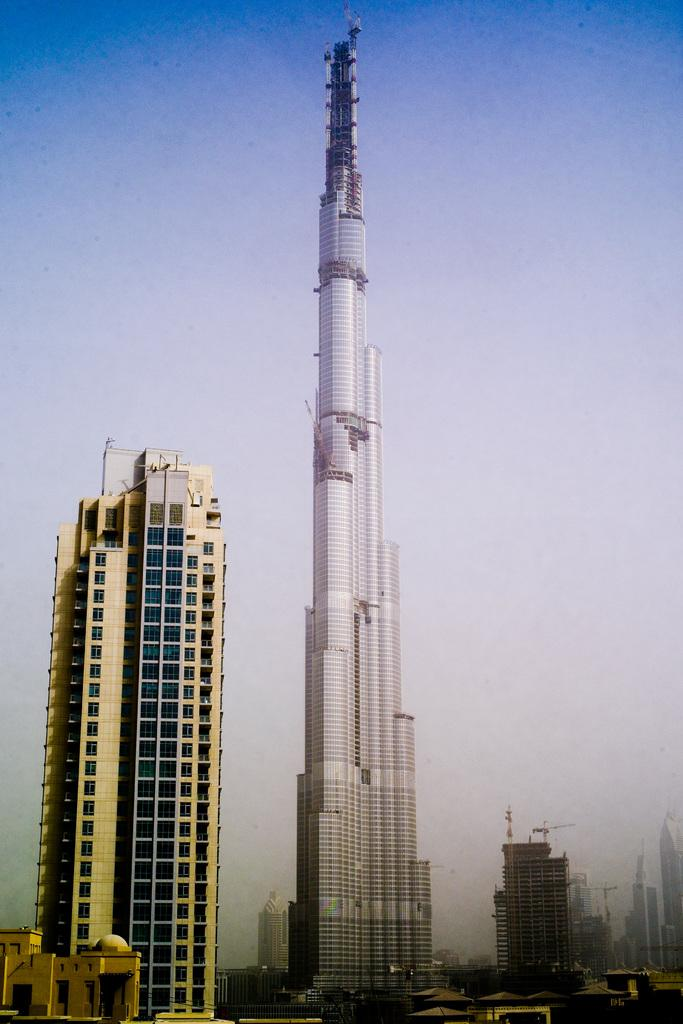What type of structures are present in the image? There are buildings in the image. What colors are the buildings? The buildings are in cream and white color. What architectural features can be seen on the buildings? There are windows visible on the buildings. What is the color of the sky in the image? The sky is in white and blue color. Where can the flower be found in the image? There is no flower present in the image. What type of waste is visible in the image? There is no waste visible in the image. 